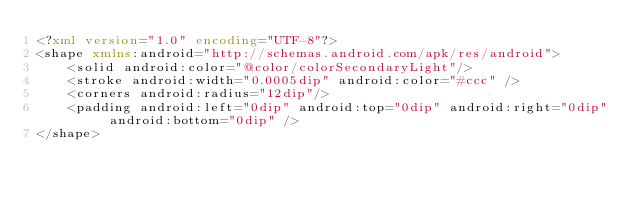Convert code to text. <code><loc_0><loc_0><loc_500><loc_500><_XML_><?xml version="1.0" encoding="UTF-8"?>
<shape xmlns:android="http://schemas.android.com/apk/res/android">
    <solid android:color="@color/colorSecondaryLight"/>
    <stroke android:width="0.0005dip" android:color="#ccc" />
    <corners android:radius="12dip"/>
    <padding android:left="0dip" android:top="0dip" android:right="0dip" android:bottom="0dip" />
</shape></code> 